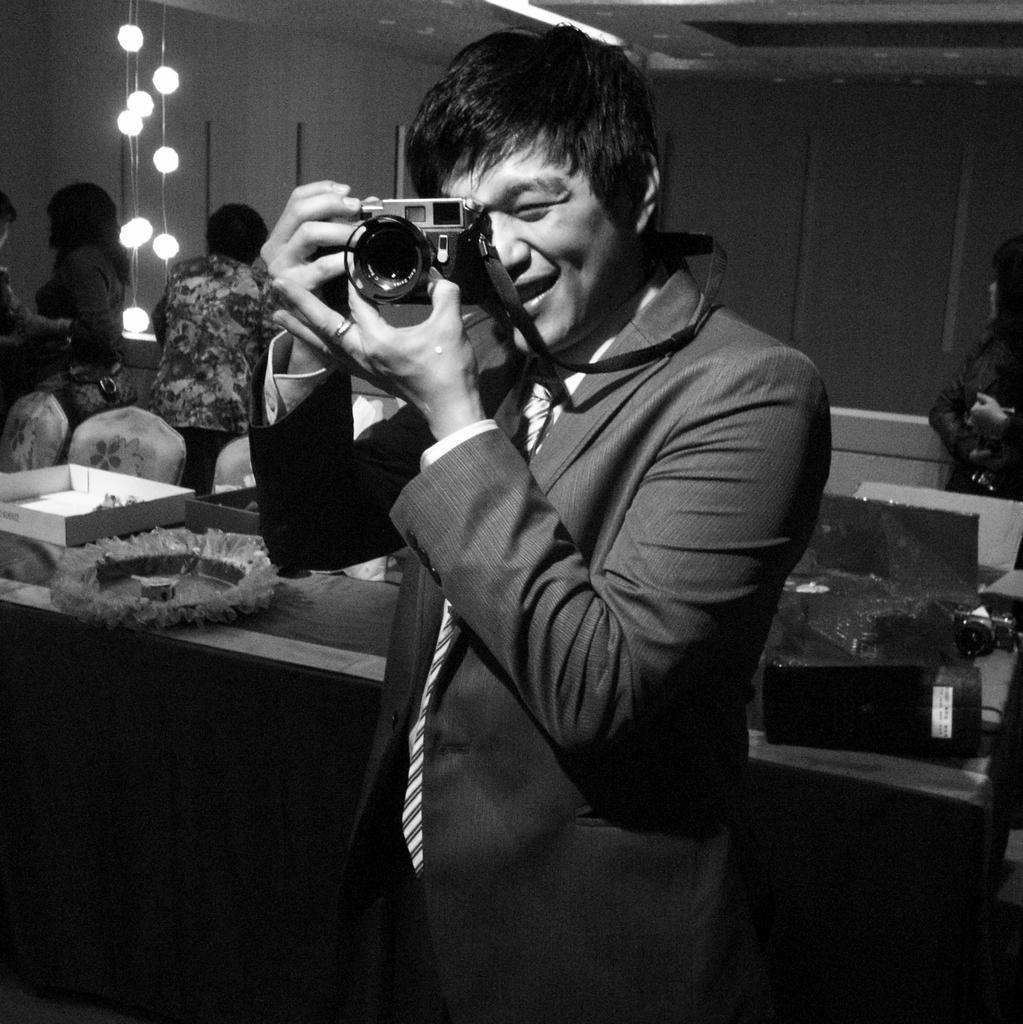Describe this image in one or two sentences. In the middle there is a man he wears suit and tie he is holding a camera. In the background there is a box, chair, people, lights, table, camera. 